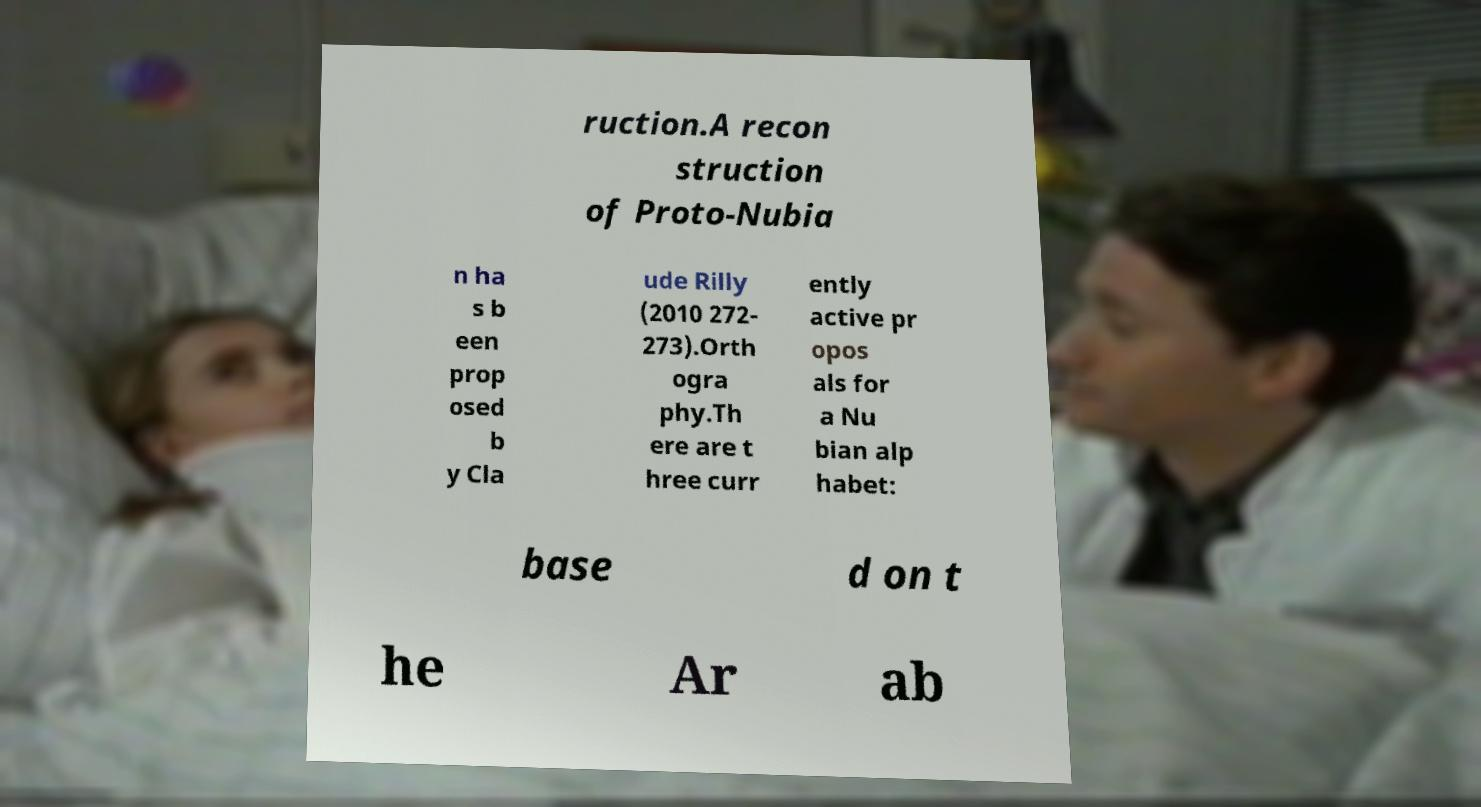I need the written content from this picture converted into text. Can you do that? ruction.A recon struction of Proto-Nubia n ha s b een prop osed b y Cla ude Rilly (2010 272- 273).Orth ogra phy.Th ere are t hree curr ently active pr opos als for a Nu bian alp habet: base d on t he Ar ab 